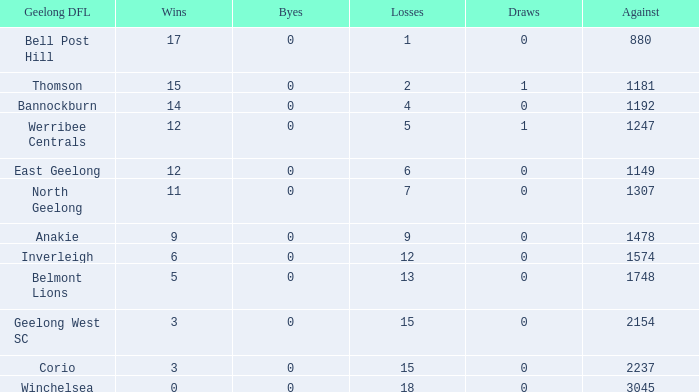Give me the full table as a dictionary. {'header': ['Geelong DFL', 'Wins', 'Byes', 'Losses', 'Draws', 'Against'], 'rows': [['Bell Post Hill', '17', '0', '1', '0', '880'], ['Thomson', '15', '0', '2', '1', '1181'], ['Bannockburn', '14', '0', '4', '0', '1192'], ['Werribee Centrals', '12', '0', '5', '1', '1247'], ['East Geelong', '12', '0', '6', '0', '1149'], ['North Geelong', '11', '0', '7', '0', '1307'], ['Anakie', '9', '0', '9', '0', '1478'], ['Inverleigh', '6', '0', '12', '0', '1574'], ['Belmont Lions', '5', '0', '13', '0', '1748'], ['Geelong West SC', '3', '0', '15', '0', '2154'], ['Corio', '3', '0', '15', '0', '2237'], ['Winchelsea', '0', '0', '18', '0', '3045']]} What are the standard losses for geelong dfl of bell post hill with draws less than 0? None. 